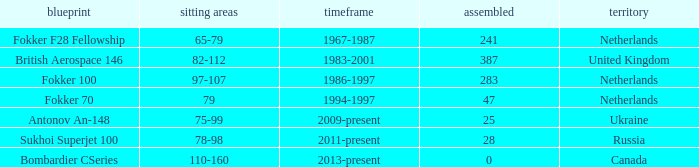Parse the full table. {'header': ['blueprint', 'sitting areas', 'timeframe', 'assembled', 'territory'], 'rows': [['Fokker F28 Fellowship', '65-79', '1967-1987', '241', 'Netherlands'], ['British Aerospace 146', '82-112', '1983-2001', '387', 'United Kingdom'], ['Fokker 100', '97-107', '1986-1997', '283', 'Netherlands'], ['Fokker 70', '79', '1994-1997', '47', 'Netherlands'], ['Antonov An-148', '75-99', '2009-present', '25', 'Ukraine'], ['Sukhoi Superjet 100', '78-98', '2011-present', '28', 'Russia'], ['Bombardier CSeries', '110-160', '2013-present', '0', 'Canada']]} Between which years were there 241 fokker 70 model cabins built? 1994-1997. 